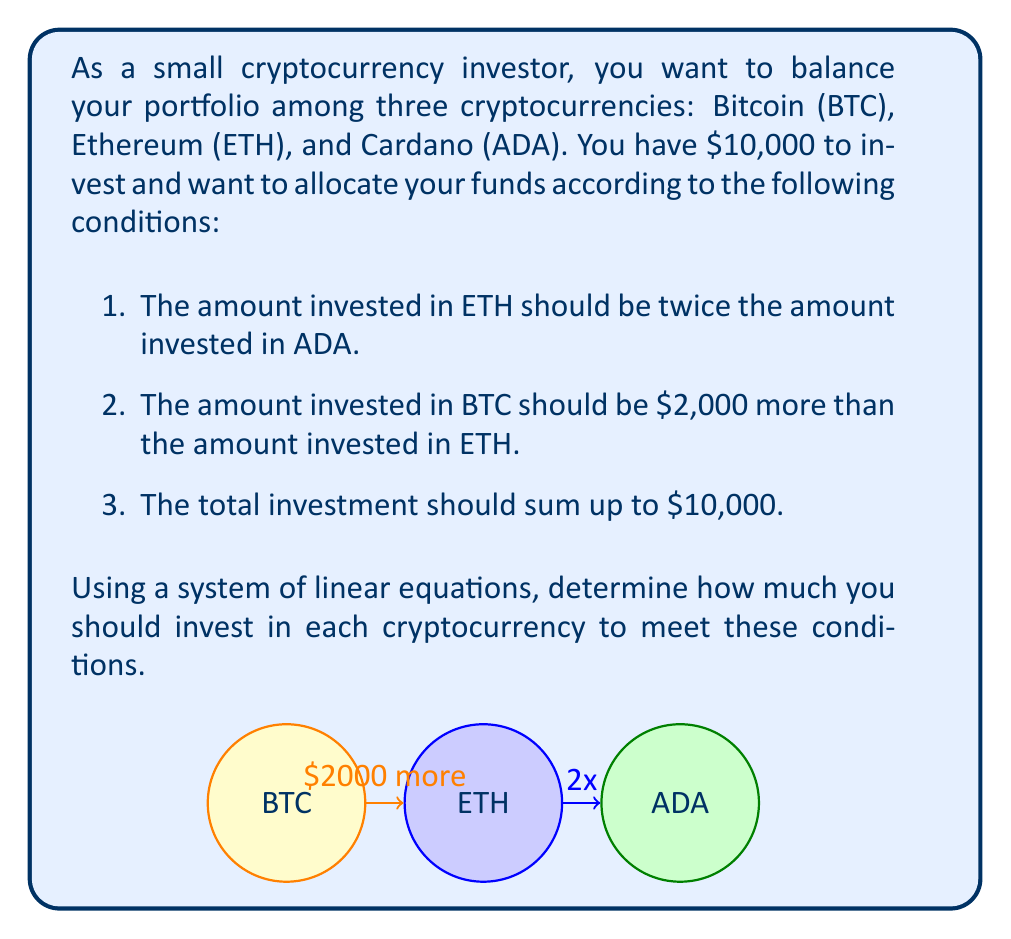Solve this math problem. Let's solve this problem step by step using a system of linear equations:

1. Define variables:
   Let $x$ = amount invested in BTC
   Let $y$ = amount invested in ETH
   Let $z$ = amount invested in ADA

2. Set up the system of equations based on the given conditions:
   $$\begin{cases}
   y = 2z & \text{(ETH is twice ADA)}\\
   x = y + 2000 & \text{(BTC is $2000 more than ETH)}\\
   x + y + z = 10000 & \text{(Total investment)}
   \end{cases}$$

3. Substitute the first equation into the second:
   $x = 2z + 2000$

4. Now we have:
   $$\begin{cases}
   x = 2z + 2000\\
   y = 2z\\
   x + y + z = 10000
   \end{cases}$$

5. Substitute these into the third equation:
   $(2z + 2000) + 2z + z = 10000$

6. Simplify:
   $5z + 2000 = 10000$

7. Solve for $z$:
   $5z = 8000$
   $z = 1600$

8. Now we can find $y$ and $x$:
   $y = 2z = 2(1600) = 3200$
   $x = y + 2000 = 3200 + 2000 = 5200$

9. Verify the solution:
   $x + y + z = 5200 + 3200 + 1600 = 10000$

Therefore, you should invest:
- $5,200 in Bitcoin (BTC)
- $3,200 in Ethereum (ETH)
- $1,600 in Cardano (ADA)
Answer: BTC: $5,200, ETH: $3,200, ADA: $1,600 